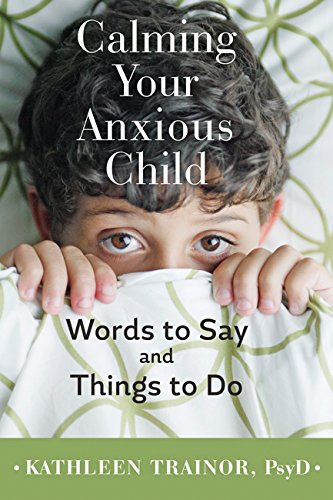Can you explain the significance of the cover design? The cover design, featuring a child peeking from behind a patterned cover, symbolizes the hidden struggles of anxiety in children and suggests the theme of uncovering and addressing these challenges through the book's content. What does the choice of colors on the cover say about the book’s theme? The calming green color scheme is often associated with tranquility and health, which aligns with the book's aim of providing soothing and therapeutic strategies for anxiety in children. 